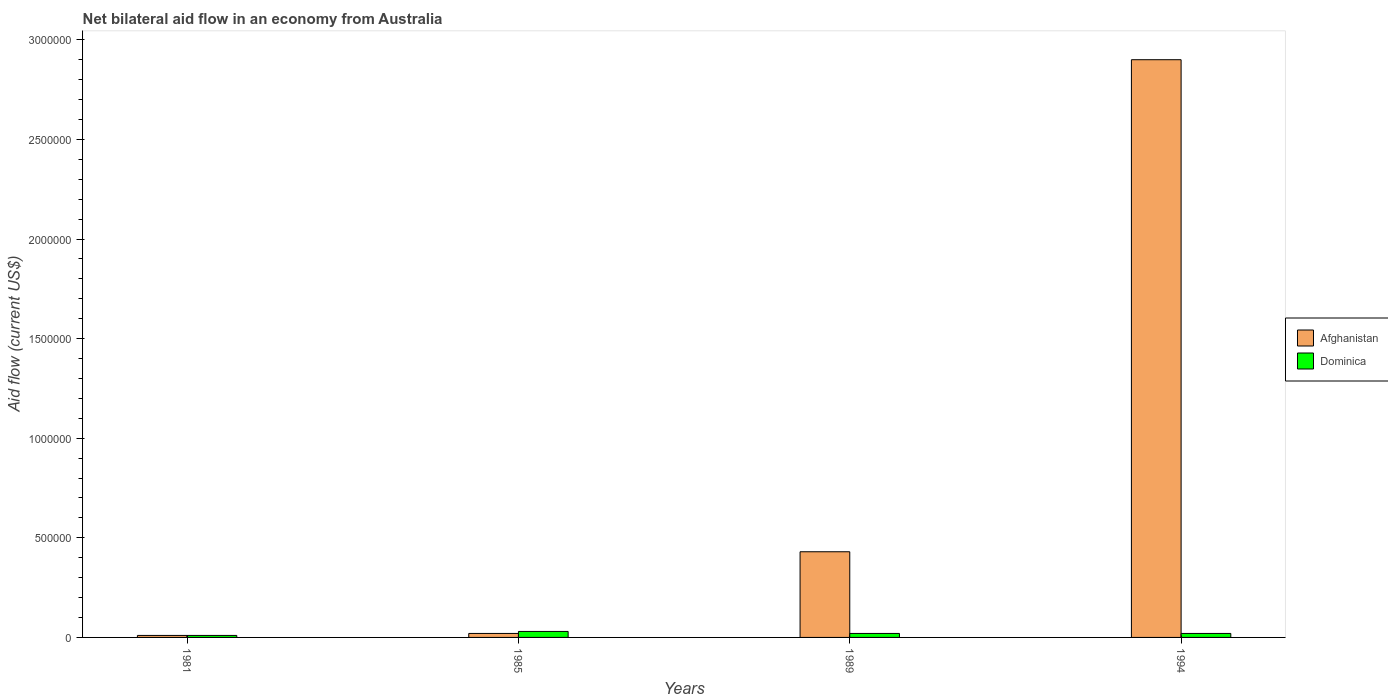How many different coloured bars are there?
Give a very brief answer. 2. How many groups of bars are there?
Give a very brief answer. 4. Are the number of bars per tick equal to the number of legend labels?
Offer a terse response. Yes. Are the number of bars on each tick of the X-axis equal?
Your response must be concise. Yes. How many bars are there on the 2nd tick from the left?
Offer a very short reply. 2. How many bars are there on the 3rd tick from the right?
Your answer should be compact. 2. What is the label of the 3rd group of bars from the left?
Make the answer very short. 1989. What is the net bilateral aid flow in Afghanistan in 1989?
Offer a very short reply. 4.30e+05. Across all years, what is the maximum net bilateral aid flow in Afghanistan?
Provide a succinct answer. 2.90e+06. Across all years, what is the minimum net bilateral aid flow in Afghanistan?
Your response must be concise. 10000. In which year was the net bilateral aid flow in Afghanistan minimum?
Provide a succinct answer. 1981. What is the total net bilateral aid flow in Afghanistan in the graph?
Keep it short and to the point. 3.36e+06. What is the difference between the net bilateral aid flow in Dominica in 1981 and the net bilateral aid flow in Afghanistan in 1994?
Provide a succinct answer. -2.89e+06. What is the ratio of the net bilateral aid flow in Dominica in 1981 to that in 1985?
Your answer should be very brief. 0.33. Is the difference between the net bilateral aid flow in Afghanistan in 1981 and 1989 greater than the difference between the net bilateral aid flow in Dominica in 1981 and 1989?
Provide a succinct answer. No. What is the difference between the highest and the second highest net bilateral aid flow in Afghanistan?
Your response must be concise. 2.47e+06. What is the difference between the highest and the lowest net bilateral aid flow in Dominica?
Provide a short and direct response. 2.00e+04. In how many years, is the net bilateral aid flow in Afghanistan greater than the average net bilateral aid flow in Afghanistan taken over all years?
Provide a short and direct response. 1. Is the sum of the net bilateral aid flow in Afghanistan in 1981 and 1985 greater than the maximum net bilateral aid flow in Dominica across all years?
Ensure brevity in your answer.  No. What does the 1st bar from the left in 1981 represents?
Keep it short and to the point. Afghanistan. What does the 2nd bar from the right in 1994 represents?
Your response must be concise. Afghanistan. Are all the bars in the graph horizontal?
Make the answer very short. No. How many years are there in the graph?
Provide a succinct answer. 4. Are the values on the major ticks of Y-axis written in scientific E-notation?
Your response must be concise. No. Does the graph contain grids?
Provide a succinct answer. No. Where does the legend appear in the graph?
Offer a very short reply. Center right. How are the legend labels stacked?
Keep it short and to the point. Vertical. What is the title of the graph?
Provide a succinct answer. Net bilateral aid flow in an economy from Australia. Does "Isle of Man" appear as one of the legend labels in the graph?
Your response must be concise. No. What is the label or title of the Y-axis?
Keep it short and to the point. Aid flow (current US$). What is the Aid flow (current US$) of Afghanistan in 1985?
Provide a short and direct response. 2.00e+04. What is the Aid flow (current US$) in Dominica in 1985?
Your response must be concise. 3.00e+04. What is the Aid flow (current US$) in Afghanistan in 1989?
Make the answer very short. 4.30e+05. What is the Aid flow (current US$) in Dominica in 1989?
Your answer should be compact. 2.00e+04. What is the Aid flow (current US$) of Afghanistan in 1994?
Your response must be concise. 2.90e+06. What is the Aid flow (current US$) of Dominica in 1994?
Ensure brevity in your answer.  2.00e+04. Across all years, what is the maximum Aid flow (current US$) of Afghanistan?
Make the answer very short. 2.90e+06. Across all years, what is the maximum Aid flow (current US$) of Dominica?
Your answer should be very brief. 3.00e+04. Across all years, what is the minimum Aid flow (current US$) in Afghanistan?
Provide a short and direct response. 10000. Across all years, what is the minimum Aid flow (current US$) in Dominica?
Ensure brevity in your answer.  10000. What is the total Aid flow (current US$) of Afghanistan in the graph?
Keep it short and to the point. 3.36e+06. What is the total Aid flow (current US$) of Dominica in the graph?
Provide a short and direct response. 8.00e+04. What is the difference between the Aid flow (current US$) in Afghanistan in 1981 and that in 1989?
Provide a succinct answer. -4.20e+05. What is the difference between the Aid flow (current US$) in Dominica in 1981 and that in 1989?
Give a very brief answer. -10000. What is the difference between the Aid flow (current US$) of Afghanistan in 1981 and that in 1994?
Your answer should be compact. -2.89e+06. What is the difference between the Aid flow (current US$) of Dominica in 1981 and that in 1994?
Provide a succinct answer. -10000. What is the difference between the Aid flow (current US$) of Afghanistan in 1985 and that in 1989?
Give a very brief answer. -4.10e+05. What is the difference between the Aid flow (current US$) of Afghanistan in 1985 and that in 1994?
Make the answer very short. -2.88e+06. What is the difference between the Aid flow (current US$) in Afghanistan in 1989 and that in 1994?
Provide a short and direct response. -2.47e+06. What is the difference between the Aid flow (current US$) of Afghanistan in 1981 and the Aid flow (current US$) of Dominica in 1989?
Offer a terse response. -10000. What is the difference between the Aid flow (current US$) of Afghanistan in 1981 and the Aid flow (current US$) of Dominica in 1994?
Provide a short and direct response. -10000. What is the average Aid flow (current US$) of Afghanistan per year?
Offer a very short reply. 8.40e+05. In the year 1981, what is the difference between the Aid flow (current US$) of Afghanistan and Aid flow (current US$) of Dominica?
Make the answer very short. 0. In the year 1985, what is the difference between the Aid flow (current US$) in Afghanistan and Aid flow (current US$) in Dominica?
Offer a very short reply. -10000. In the year 1994, what is the difference between the Aid flow (current US$) in Afghanistan and Aid flow (current US$) in Dominica?
Your answer should be compact. 2.88e+06. What is the ratio of the Aid flow (current US$) of Dominica in 1981 to that in 1985?
Give a very brief answer. 0.33. What is the ratio of the Aid flow (current US$) of Afghanistan in 1981 to that in 1989?
Offer a terse response. 0.02. What is the ratio of the Aid flow (current US$) of Dominica in 1981 to that in 1989?
Offer a very short reply. 0.5. What is the ratio of the Aid flow (current US$) of Afghanistan in 1981 to that in 1994?
Keep it short and to the point. 0. What is the ratio of the Aid flow (current US$) in Afghanistan in 1985 to that in 1989?
Keep it short and to the point. 0.05. What is the ratio of the Aid flow (current US$) of Dominica in 1985 to that in 1989?
Give a very brief answer. 1.5. What is the ratio of the Aid flow (current US$) in Afghanistan in 1985 to that in 1994?
Provide a short and direct response. 0.01. What is the ratio of the Aid flow (current US$) in Afghanistan in 1989 to that in 1994?
Your response must be concise. 0.15. What is the difference between the highest and the second highest Aid flow (current US$) in Afghanistan?
Provide a short and direct response. 2.47e+06. What is the difference between the highest and the second highest Aid flow (current US$) of Dominica?
Provide a succinct answer. 10000. What is the difference between the highest and the lowest Aid flow (current US$) in Afghanistan?
Offer a terse response. 2.89e+06. What is the difference between the highest and the lowest Aid flow (current US$) of Dominica?
Keep it short and to the point. 2.00e+04. 